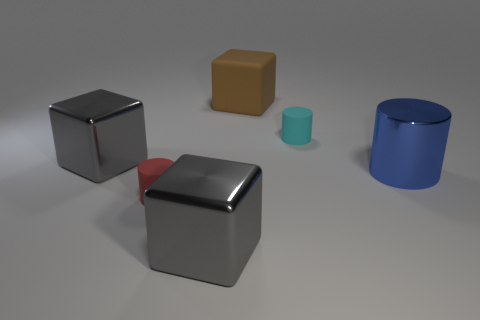Subtract all brown cylinders. Subtract all purple cubes. How many cylinders are left? 3 Add 3 big rubber blocks. How many objects exist? 9 Subtract 0 yellow blocks. How many objects are left? 6 Subtract all large yellow rubber balls. Subtract all rubber things. How many objects are left? 3 Add 5 large gray metal objects. How many large gray metal objects are left? 7 Add 1 brown metallic things. How many brown metallic things exist? 1 